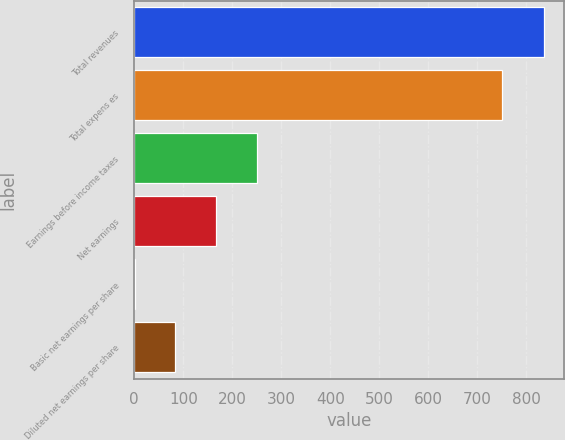Convert chart. <chart><loc_0><loc_0><loc_500><loc_500><bar_chart><fcel>Total revenues<fcel>Total expens es<fcel>Earnings before income taxes<fcel>Net earnings<fcel>Basic net earnings per share<fcel>Diluted net earnings per share<nl><fcel>835.8<fcel>750.3<fcel>251.13<fcel>167.61<fcel>0.57<fcel>84.09<nl></chart> 